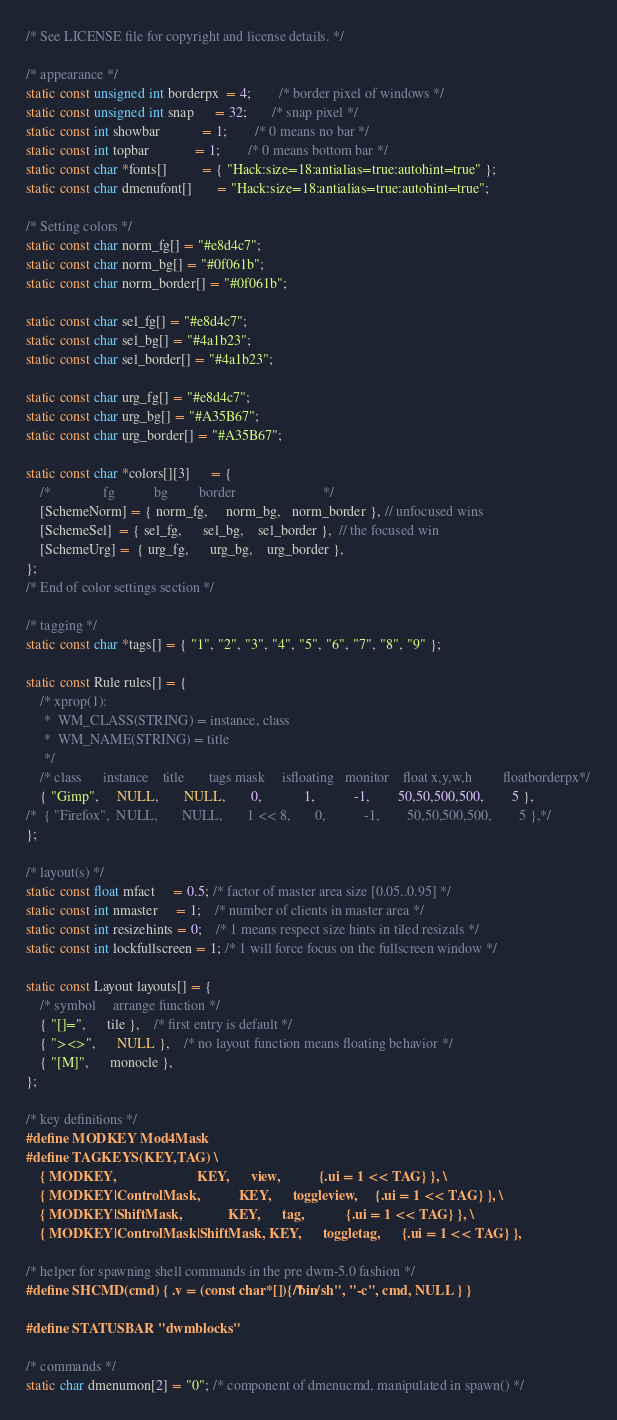<code> <loc_0><loc_0><loc_500><loc_500><_C_>/* See LICENSE file for copyright and license details. */

/* appearance */
static const unsigned int borderpx  = 4;        /* border pixel of windows */
static const unsigned int snap      = 32;       /* snap pixel */
static const int showbar            = 1;        /* 0 means no bar */
static const int topbar             = 1;        /* 0 means bottom bar */
static const char *fonts[]          = { "Hack:size=18:antialias=true:autohint=true" };
static const char dmenufont[]       = "Hack:size=18:antialias=true:autohint=true";

/* Setting colors */
static const char norm_fg[] = "#e8d4c7";
static const char norm_bg[] = "#0f061b";
static const char norm_border[] = "#0f061b";

static const char sel_fg[] = "#e8d4c7";
static const char sel_bg[] = "#4a1b23";
static const char sel_border[] = "#4a1b23";

static const char urg_fg[] = "#e8d4c7";
static const char urg_bg[] = "#A35B67";
static const char urg_border[] = "#A35B67";

static const char *colors[][3]      = {
    /*               fg           bg         border                         */
    [SchemeNorm] = { norm_fg,     norm_bg,   norm_border }, // unfocused wins
    [SchemeSel]  = { sel_fg,      sel_bg,    sel_border },  // the focused win
    [SchemeUrg] =  { urg_fg,      urg_bg,    urg_border },
};
/* End of color settings section */

/* tagging */
static const char *tags[] = { "1", "2", "3", "4", "5", "6", "7", "8", "9" };

static const Rule rules[] = {
	/* xprop(1):
	 *	WM_CLASS(STRING) = instance, class
	 *	WM_NAME(STRING) = title
	 */
	/* class      instance    title       tags mask     isfloating   monitor    float x,y,w,h         floatborderpx*/
	{ "Gimp",     NULL,       NULL,       0,            1,           -1,        50,50,500,500,        5 },
/*	{ "Firefox",  NULL,       NULL,       1 << 8,       0,           -1,        50,50,500,500,        5 },*/
};

/* layout(s) */
static const float mfact     = 0.5; /* factor of master area size [0.05..0.95] */
static const int nmaster     = 1;    /* number of clients in master area */
static const int resizehints = 0;    /* 1 means respect size hints in tiled resizals */
static const int lockfullscreen = 1; /* 1 will force focus on the fullscreen window */

static const Layout layouts[] = {
	/* symbol     arrange function */
	{ "[]=",      tile },    /* first entry is default */
	{ "><>",      NULL },    /* no layout function means floating behavior */
	{ "[M]",      monocle },
};

/* key definitions */
#define MODKEY Mod4Mask
#define TAGKEYS(KEY,TAG) \
	{ MODKEY,                       KEY,      view,           {.ui = 1 << TAG} }, \
	{ MODKEY|ControlMask,           KEY,      toggleview,     {.ui = 1 << TAG} }, \
	{ MODKEY|ShiftMask,             KEY,      tag,            {.ui = 1 << TAG} }, \
	{ MODKEY|ControlMask|ShiftMask, KEY,      toggletag,      {.ui = 1 << TAG} },

/* helper for spawning shell commands in the pre dwm-5.0 fashion */
#define SHCMD(cmd) { .v = (const char*[]){ "/bin/sh", "-c", cmd, NULL } }

#define STATUSBAR "dwmblocks"

/* commands */
static char dmenumon[2] = "0"; /* component of dmenucmd, manipulated in spawn() */</code> 